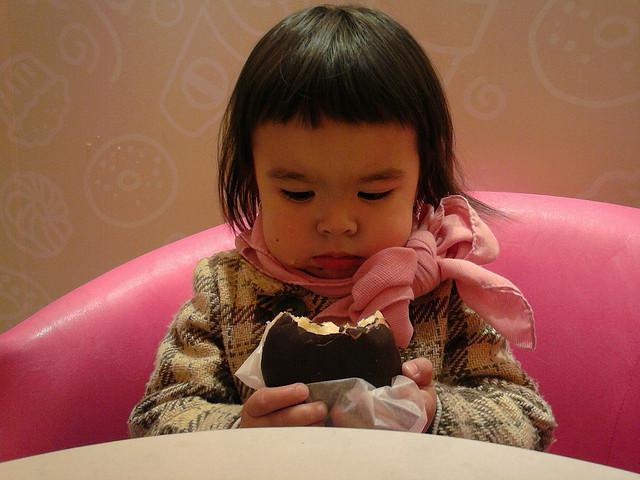How many girls are present?
Give a very brief answer. 1. How many donuts are in the picture?
Give a very brief answer. 1. 